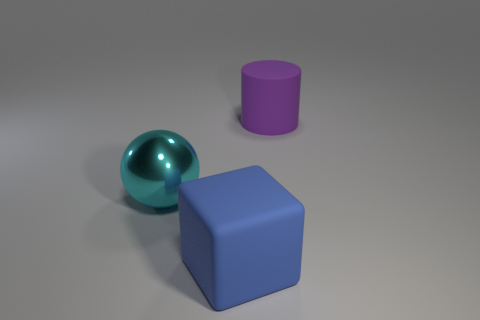Does the object right of the large blue cube have the same material as the large blue thing?
Keep it short and to the point. Yes. Are there fewer large cyan balls that are behind the big cyan object than purple metal balls?
Provide a succinct answer. No. The rubber thing behind the big cyan metal sphere has what shape?
Make the answer very short. Cylinder. What shape is the blue matte thing that is the same size as the purple cylinder?
Offer a terse response. Cube. Is there a big purple matte thing of the same shape as the big metal thing?
Offer a very short reply. No. Is the shape of the big object that is on the right side of the big block the same as the rubber thing in front of the big ball?
Provide a succinct answer. No. There is a block that is the same size as the cyan ball; what is its material?
Your answer should be compact. Rubber. What number of other things are there of the same material as the large blue object
Your answer should be very brief. 1. The matte thing in front of the big rubber object that is behind the large cyan shiny ball is what shape?
Provide a short and direct response. Cube. How many things are either tiny shiny cubes or objects that are to the right of the blue object?
Ensure brevity in your answer.  1. 